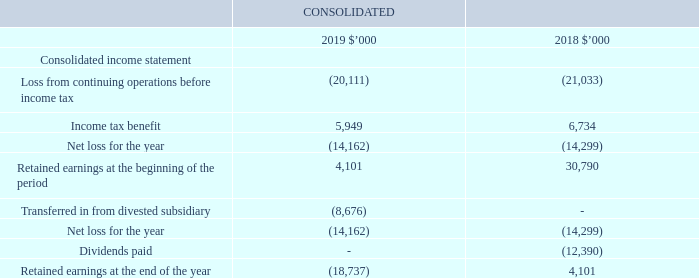6.4 Deed of cross guarantee
Pursuant to the iSelect Deed of Cross Guarantee (“the Deed”) and in accordance with ASIC Class Order 98/1418, the subsidiaries identified with a ‘2’ in note 6.2 are relieved from the requirements of the Corporations Act 2001 relating to the preparation, audit and lodgment of their financial reports.
iSelect Limited and the subsidiaries identified with a ‘2’ in note 6.2 together are referred to as the “Closed Group”. The Closed Group, with the exception of General Brokerage Services Pty Ltd, Energy Watch Trading Pty Ltd, Procure Power Pty Ltd, Energy Watch Services Pty Ltd and iSelect International Pty Ltd entered into the Deed on 26 June 2013.
General Brokerage Services Pty Ltd, Energy Watch Trading Pty Ltd, Procure Power Pty Ltd and Energy Watch Services Pty Ltd entered into the Deed on 1 July 2014, the date they were acquired as part of the Energy Watch Group acquisition. iSelect International entered the Deed on 8 September 2014. The effect of the Deed is that iSelect Limited guarantees to each creditor payment in full of any debt in the event of winding up any of the entities in the Closed Group.
The consolidated income statement of the entities that are members of the Closed Group is as follows:
What is the effect of the Deed? Iselect limited guarantees to each creditor payment in full of any debt in the event of winding up any of the entities in the closed group. What is the income tax benefit in 2019?
Answer scale should be: thousand. 5,949. What is the loss from continuing operations before income tax in 2019?
Answer scale should be: thousand. 20,111. What is the percentage change in the Loss from continuing operations before income tax from 2018 to 2019?
Answer scale should be: percent. (20,111-21,033)/21,033
Answer: -4.38. What is the percentage change in the income tax benefit from 2018 to 2019?
Answer scale should be: percent. (5,949-6,734)/6,734
Answer: -11.66. In which year is there a greater net loss for the year? Find the year with the greater net loss for the year
Answer: 2018. 